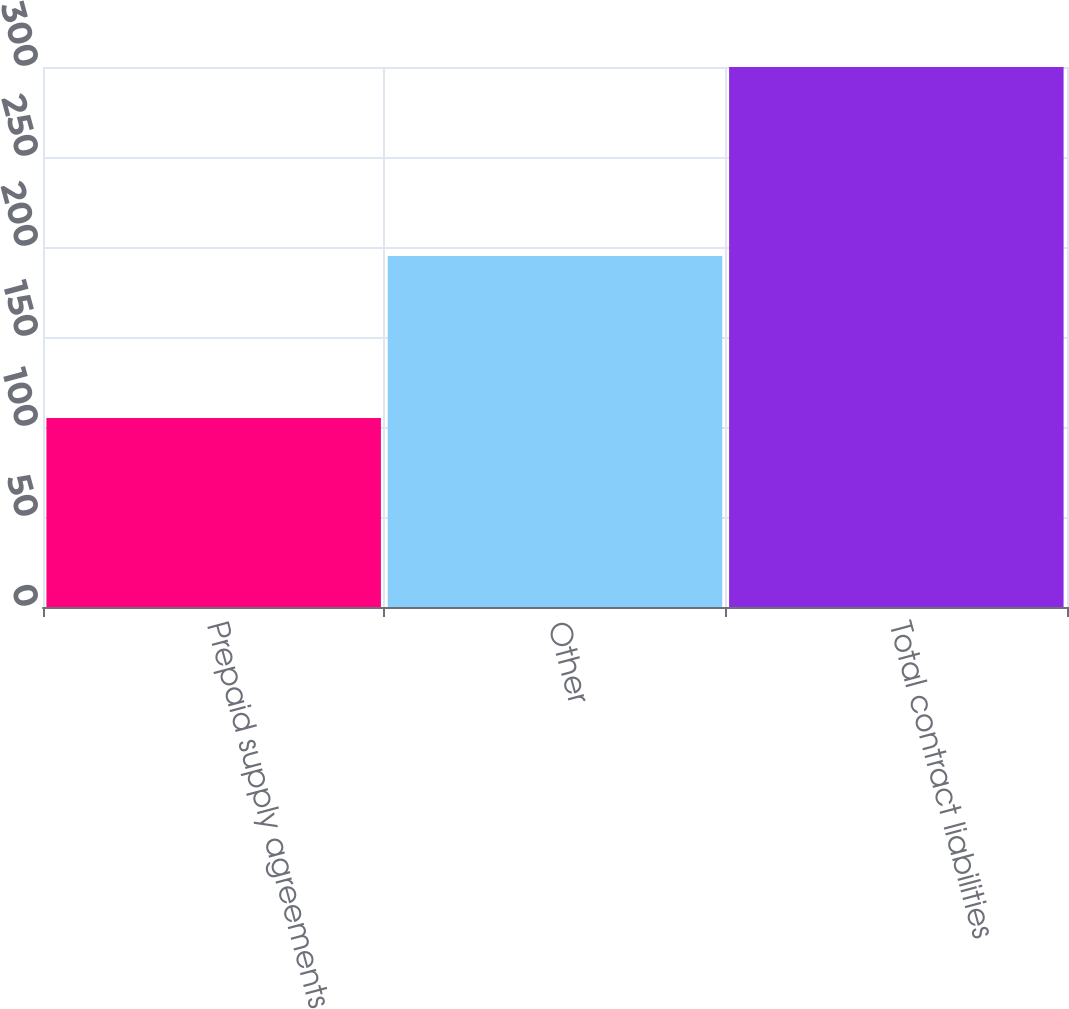Convert chart. <chart><loc_0><loc_0><loc_500><loc_500><bar_chart><fcel>Prepaid supply agreements<fcel>Other<fcel>Total contract liabilities<nl><fcel>105<fcel>195<fcel>300<nl></chart> 